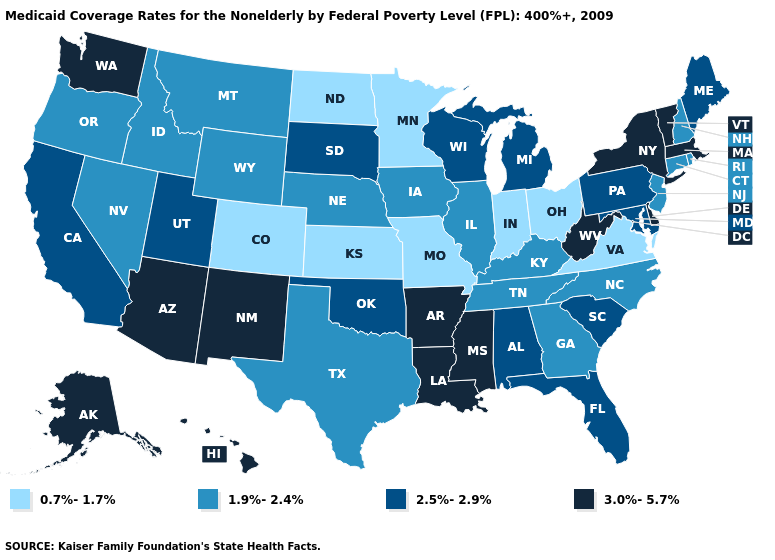Among the states that border Illinois , does Missouri have the highest value?
Short answer required. No. Which states hav the highest value in the South?
Concise answer only. Arkansas, Delaware, Louisiana, Mississippi, West Virginia. Name the states that have a value in the range 2.5%-2.9%?
Answer briefly. Alabama, California, Florida, Maine, Maryland, Michigan, Oklahoma, Pennsylvania, South Carolina, South Dakota, Utah, Wisconsin. What is the highest value in states that border Maine?
Write a very short answer. 1.9%-2.4%. Is the legend a continuous bar?
Quick response, please. No. What is the lowest value in states that border Alabama?
Quick response, please. 1.9%-2.4%. Which states have the highest value in the USA?
Give a very brief answer. Alaska, Arizona, Arkansas, Delaware, Hawaii, Louisiana, Massachusetts, Mississippi, New Mexico, New York, Vermont, Washington, West Virginia. Which states have the highest value in the USA?
Write a very short answer. Alaska, Arizona, Arkansas, Delaware, Hawaii, Louisiana, Massachusetts, Mississippi, New Mexico, New York, Vermont, Washington, West Virginia. What is the value of Pennsylvania?
Write a very short answer. 2.5%-2.9%. Name the states that have a value in the range 2.5%-2.9%?
Be succinct. Alabama, California, Florida, Maine, Maryland, Michigan, Oklahoma, Pennsylvania, South Carolina, South Dakota, Utah, Wisconsin. Among the states that border Rhode Island , does Massachusetts have the lowest value?
Short answer required. No. What is the value of Virginia?
Short answer required. 0.7%-1.7%. Does the map have missing data?
Keep it brief. No. What is the highest value in the MidWest ?
Be succinct. 2.5%-2.9%. 